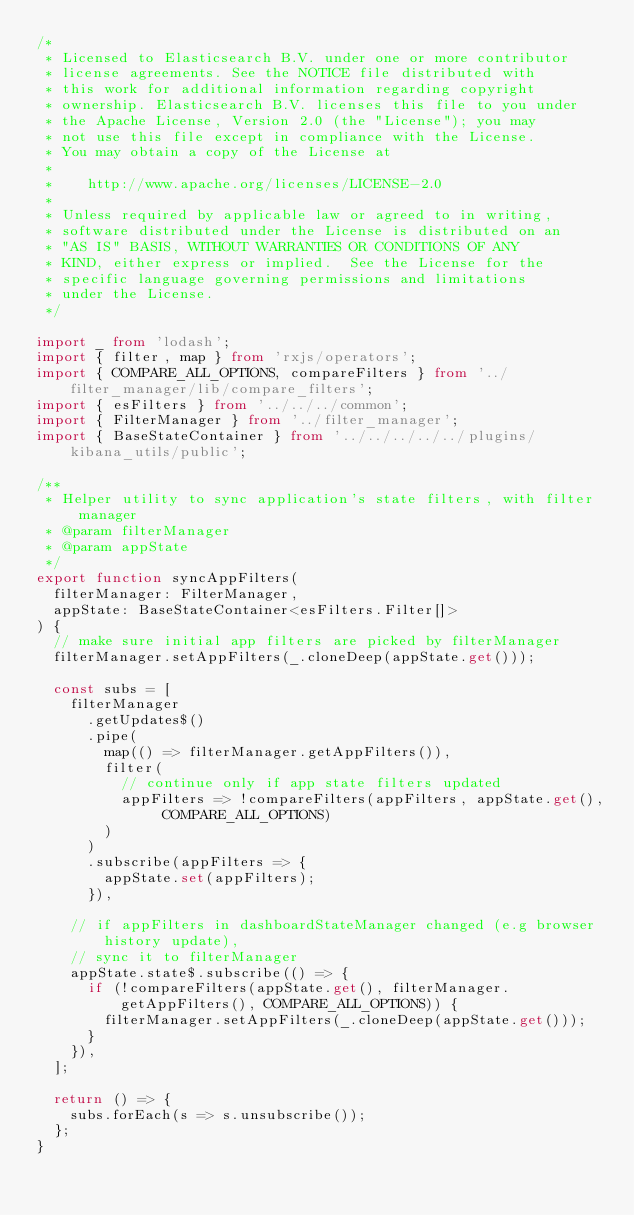Convert code to text. <code><loc_0><loc_0><loc_500><loc_500><_TypeScript_>/*
 * Licensed to Elasticsearch B.V. under one or more contributor
 * license agreements. See the NOTICE file distributed with
 * this work for additional information regarding copyright
 * ownership. Elasticsearch B.V. licenses this file to you under
 * the Apache License, Version 2.0 (the "License"); you may
 * not use this file except in compliance with the License.
 * You may obtain a copy of the License at
 *
 *    http://www.apache.org/licenses/LICENSE-2.0
 *
 * Unless required by applicable law or agreed to in writing,
 * software distributed under the License is distributed on an
 * "AS IS" BASIS, WITHOUT WARRANTIES OR CONDITIONS OF ANY
 * KIND, either express or implied.  See the License for the
 * specific language governing permissions and limitations
 * under the License.
 */

import _ from 'lodash';
import { filter, map } from 'rxjs/operators';
import { COMPARE_ALL_OPTIONS, compareFilters } from '../filter_manager/lib/compare_filters';
import { esFilters } from '../../../common';
import { FilterManager } from '../filter_manager';
import { BaseStateContainer } from '../../../../../plugins/kibana_utils/public';

/**
 * Helper utility to sync application's state filters, with filter manager
 * @param filterManager
 * @param appState
 */
export function syncAppFilters(
  filterManager: FilterManager,
  appState: BaseStateContainer<esFilters.Filter[]>
) {
  // make sure initial app filters are picked by filterManager
  filterManager.setAppFilters(_.cloneDeep(appState.get()));

  const subs = [
    filterManager
      .getUpdates$()
      .pipe(
        map(() => filterManager.getAppFilters()),
        filter(
          // continue only if app state filters updated
          appFilters => !compareFilters(appFilters, appState.get(), COMPARE_ALL_OPTIONS)
        )
      )
      .subscribe(appFilters => {
        appState.set(appFilters);
      }),

    // if appFilters in dashboardStateManager changed (e.g browser history update),
    // sync it to filterManager
    appState.state$.subscribe(() => {
      if (!compareFilters(appState.get(), filterManager.getAppFilters(), COMPARE_ALL_OPTIONS)) {
        filterManager.setAppFilters(_.cloneDeep(appState.get()));
      }
    }),
  ];

  return () => {
    subs.forEach(s => s.unsubscribe());
  };
}
</code> 